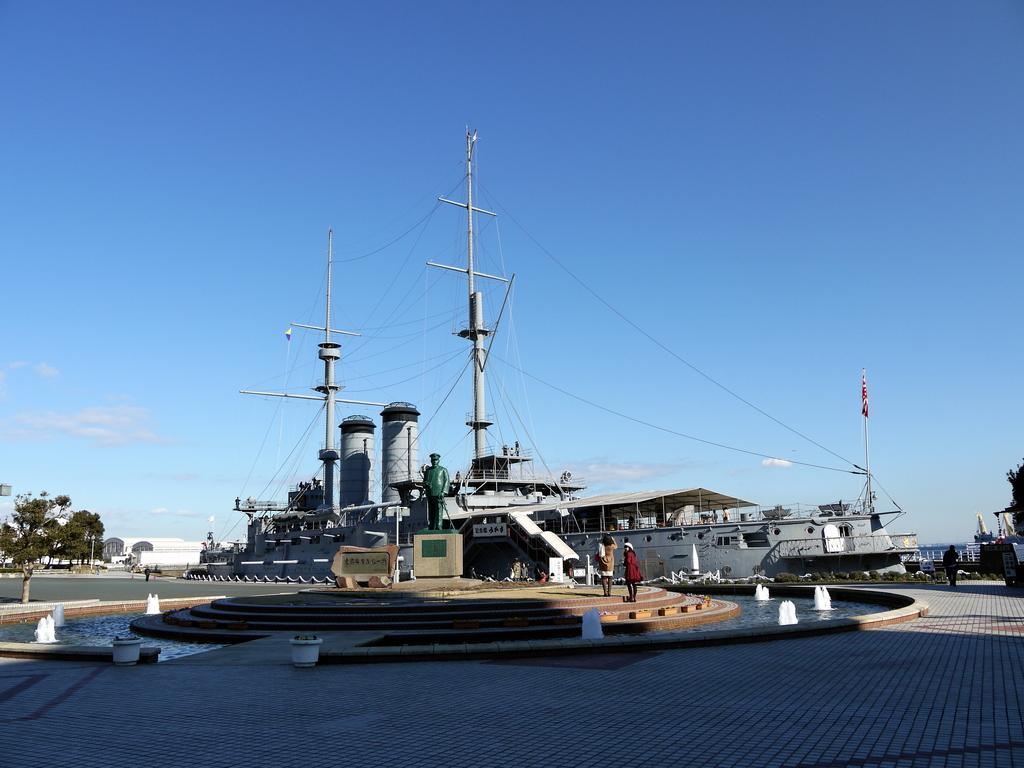Can you describe this image briefly? As we can see in the image there are boats, statue, few people here and there, stairs, current poles and trees. On the top there is sky. 